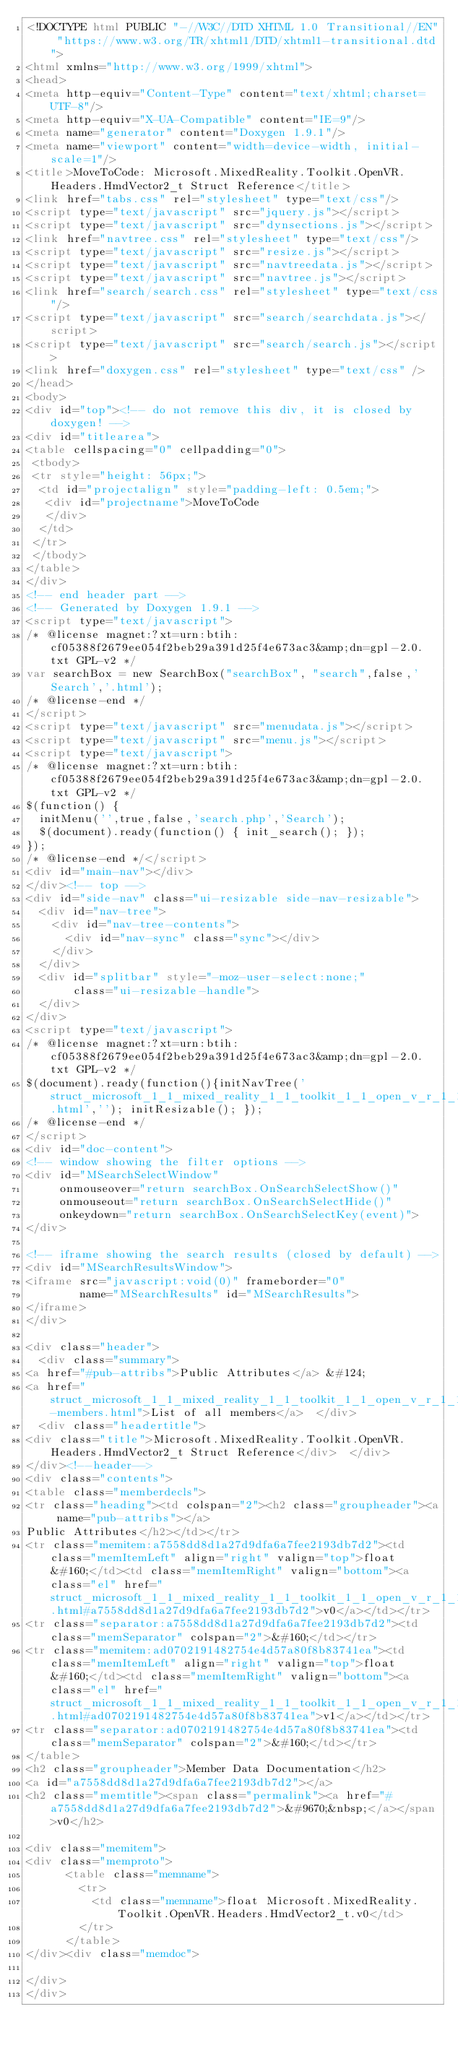Convert code to text. <code><loc_0><loc_0><loc_500><loc_500><_HTML_><!DOCTYPE html PUBLIC "-//W3C//DTD XHTML 1.0 Transitional//EN" "https://www.w3.org/TR/xhtml1/DTD/xhtml1-transitional.dtd">
<html xmlns="http://www.w3.org/1999/xhtml">
<head>
<meta http-equiv="Content-Type" content="text/xhtml;charset=UTF-8"/>
<meta http-equiv="X-UA-Compatible" content="IE=9"/>
<meta name="generator" content="Doxygen 1.9.1"/>
<meta name="viewport" content="width=device-width, initial-scale=1"/>
<title>MoveToCode: Microsoft.MixedReality.Toolkit.OpenVR.Headers.HmdVector2_t Struct Reference</title>
<link href="tabs.css" rel="stylesheet" type="text/css"/>
<script type="text/javascript" src="jquery.js"></script>
<script type="text/javascript" src="dynsections.js"></script>
<link href="navtree.css" rel="stylesheet" type="text/css"/>
<script type="text/javascript" src="resize.js"></script>
<script type="text/javascript" src="navtreedata.js"></script>
<script type="text/javascript" src="navtree.js"></script>
<link href="search/search.css" rel="stylesheet" type="text/css"/>
<script type="text/javascript" src="search/searchdata.js"></script>
<script type="text/javascript" src="search/search.js"></script>
<link href="doxygen.css" rel="stylesheet" type="text/css" />
</head>
<body>
<div id="top"><!-- do not remove this div, it is closed by doxygen! -->
<div id="titlearea">
<table cellspacing="0" cellpadding="0">
 <tbody>
 <tr style="height: 56px;">
  <td id="projectalign" style="padding-left: 0.5em;">
   <div id="projectname">MoveToCode
   </div>
  </td>
 </tr>
 </tbody>
</table>
</div>
<!-- end header part -->
<!-- Generated by Doxygen 1.9.1 -->
<script type="text/javascript">
/* @license magnet:?xt=urn:btih:cf05388f2679ee054f2beb29a391d25f4e673ac3&amp;dn=gpl-2.0.txt GPL-v2 */
var searchBox = new SearchBox("searchBox", "search",false,'Search','.html');
/* @license-end */
</script>
<script type="text/javascript" src="menudata.js"></script>
<script type="text/javascript" src="menu.js"></script>
<script type="text/javascript">
/* @license magnet:?xt=urn:btih:cf05388f2679ee054f2beb29a391d25f4e673ac3&amp;dn=gpl-2.0.txt GPL-v2 */
$(function() {
  initMenu('',true,false,'search.php','Search');
  $(document).ready(function() { init_search(); });
});
/* @license-end */</script>
<div id="main-nav"></div>
</div><!-- top -->
<div id="side-nav" class="ui-resizable side-nav-resizable">
  <div id="nav-tree">
    <div id="nav-tree-contents">
      <div id="nav-sync" class="sync"></div>
    </div>
  </div>
  <div id="splitbar" style="-moz-user-select:none;" 
       class="ui-resizable-handle">
  </div>
</div>
<script type="text/javascript">
/* @license magnet:?xt=urn:btih:cf05388f2679ee054f2beb29a391d25f4e673ac3&amp;dn=gpl-2.0.txt GPL-v2 */
$(document).ready(function(){initNavTree('struct_microsoft_1_1_mixed_reality_1_1_toolkit_1_1_open_v_r_1_1_headers_1_1_hmd_vector2__t.html',''); initResizable(); });
/* @license-end */
</script>
<div id="doc-content">
<!-- window showing the filter options -->
<div id="MSearchSelectWindow"
     onmouseover="return searchBox.OnSearchSelectShow()"
     onmouseout="return searchBox.OnSearchSelectHide()"
     onkeydown="return searchBox.OnSearchSelectKey(event)">
</div>

<!-- iframe showing the search results (closed by default) -->
<div id="MSearchResultsWindow">
<iframe src="javascript:void(0)" frameborder="0" 
        name="MSearchResults" id="MSearchResults">
</iframe>
</div>

<div class="header">
  <div class="summary">
<a href="#pub-attribs">Public Attributes</a> &#124;
<a href="struct_microsoft_1_1_mixed_reality_1_1_toolkit_1_1_open_v_r_1_1_headers_1_1_hmd_vector2__t-members.html">List of all members</a>  </div>
  <div class="headertitle">
<div class="title">Microsoft.MixedReality.Toolkit.OpenVR.Headers.HmdVector2_t Struct Reference</div>  </div>
</div><!--header-->
<div class="contents">
<table class="memberdecls">
<tr class="heading"><td colspan="2"><h2 class="groupheader"><a name="pub-attribs"></a>
Public Attributes</h2></td></tr>
<tr class="memitem:a7558dd8d1a27d9dfa6a7fee2193db7d2"><td class="memItemLeft" align="right" valign="top">float&#160;</td><td class="memItemRight" valign="bottom"><a class="el" href="struct_microsoft_1_1_mixed_reality_1_1_toolkit_1_1_open_v_r_1_1_headers_1_1_hmd_vector2__t.html#a7558dd8d1a27d9dfa6a7fee2193db7d2">v0</a></td></tr>
<tr class="separator:a7558dd8d1a27d9dfa6a7fee2193db7d2"><td class="memSeparator" colspan="2">&#160;</td></tr>
<tr class="memitem:ad0702191482754e4d57a80f8b83741ea"><td class="memItemLeft" align="right" valign="top">float&#160;</td><td class="memItemRight" valign="bottom"><a class="el" href="struct_microsoft_1_1_mixed_reality_1_1_toolkit_1_1_open_v_r_1_1_headers_1_1_hmd_vector2__t.html#ad0702191482754e4d57a80f8b83741ea">v1</a></td></tr>
<tr class="separator:ad0702191482754e4d57a80f8b83741ea"><td class="memSeparator" colspan="2">&#160;</td></tr>
</table>
<h2 class="groupheader">Member Data Documentation</h2>
<a id="a7558dd8d1a27d9dfa6a7fee2193db7d2"></a>
<h2 class="memtitle"><span class="permalink"><a href="#a7558dd8d1a27d9dfa6a7fee2193db7d2">&#9670;&nbsp;</a></span>v0</h2>

<div class="memitem">
<div class="memproto">
      <table class="memname">
        <tr>
          <td class="memname">float Microsoft.MixedReality.Toolkit.OpenVR.Headers.HmdVector2_t.v0</td>
        </tr>
      </table>
</div><div class="memdoc">

</div>
</div></code> 